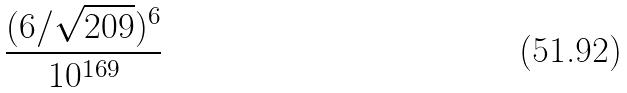Convert formula to latex. <formula><loc_0><loc_0><loc_500><loc_500>\frac { ( 6 / \sqrt { 2 0 9 } ) ^ { 6 } } { 1 0 ^ { 1 6 9 } }</formula> 